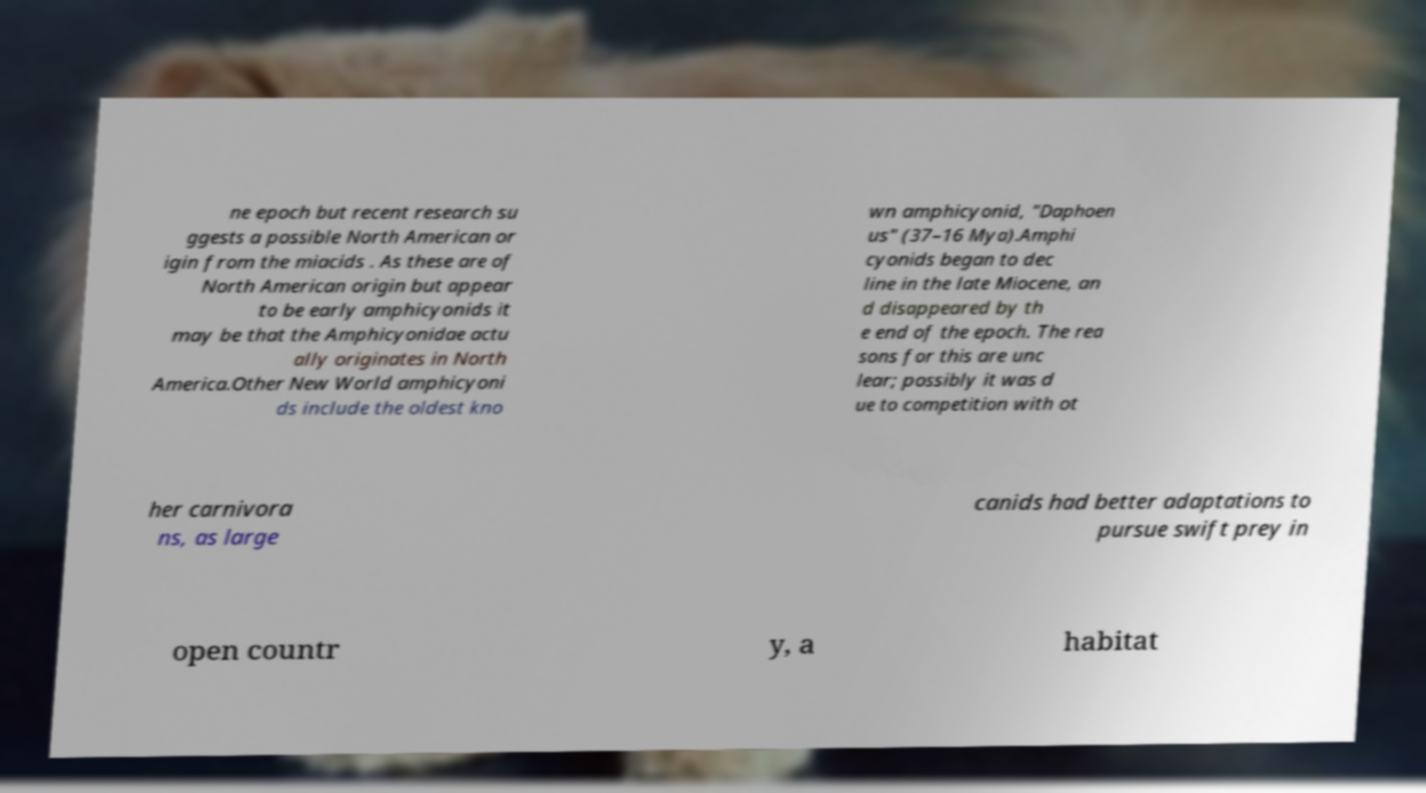There's text embedded in this image that I need extracted. Can you transcribe it verbatim? ne epoch but recent research su ggests a possible North American or igin from the miacids . As these are of North American origin but appear to be early amphicyonids it may be that the Amphicyonidae actu ally originates in North America.Other New World amphicyoni ds include the oldest kno wn amphicyonid, "Daphoen us" (37–16 Mya).Amphi cyonids began to dec line in the late Miocene, an d disappeared by th e end of the epoch. The rea sons for this are unc lear; possibly it was d ue to competition with ot her carnivora ns, as large canids had better adaptations to pursue swift prey in open countr y, a habitat 